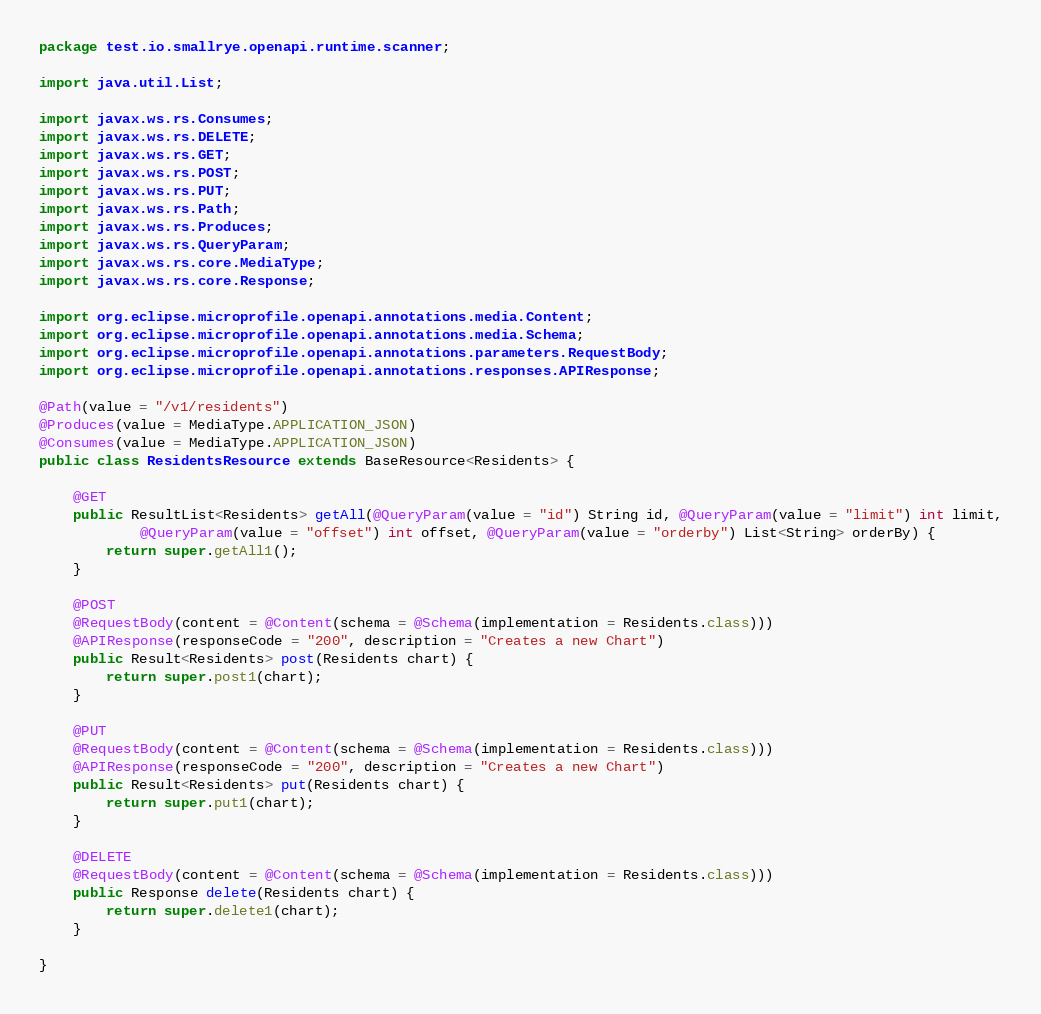<code> <loc_0><loc_0><loc_500><loc_500><_Java_>package test.io.smallrye.openapi.runtime.scanner;

import java.util.List;

import javax.ws.rs.Consumes;
import javax.ws.rs.DELETE;
import javax.ws.rs.GET;
import javax.ws.rs.POST;
import javax.ws.rs.PUT;
import javax.ws.rs.Path;
import javax.ws.rs.Produces;
import javax.ws.rs.QueryParam;
import javax.ws.rs.core.MediaType;
import javax.ws.rs.core.Response;

import org.eclipse.microprofile.openapi.annotations.media.Content;
import org.eclipse.microprofile.openapi.annotations.media.Schema;
import org.eclipse.microprofile.openapi.annotations.parameters.RequestBody;
import org.eclipse.microprofile.openapi.annotations.responses.APIResponse;

@Path(value = "/v1/residents")
@Produces(value = MediaType.APPLICATION_JSON)
@Consumes(value = MediaType.APPLICATION_JSON)
public class ResidentsResource extends BaseResource<Residents> {

    @GET
    public ResultList<Residents> getAll(@QueryParam(value = "id") String id, @QueryParam(value = "limit") int limit,
            @QueryParam(value = "offset") int offset, @QueryParam(value = "orderby") List<String> orderBy) {
        return super.getAll1();
    }

    @POST
    @RequestBody(content = @Content(schema = @Schema(implementation = Residents.class)))
    @APIResponse(responseCode = "200", description = "Creates a new Chart")
    public Result<Residents> post(Residents chart) {
        return super.post1(chart);
    }

    @PUT
    @RequestBody(content = @Content(schema = @Schema(implementation = Residents.class)))
    @APIResponse(responseCode = "200", description = "Creates a new Chart")
    public Result<Residents> put(Residents chart) {
        return super.put1(chart);
    }

    @DELETE
    @RequestBody(content = @Content(schema = @Schema(implementation = Residents.class)))
    public Response delete(Residents chart) {
        return super.delete1(chart);
    }

}
</code> 